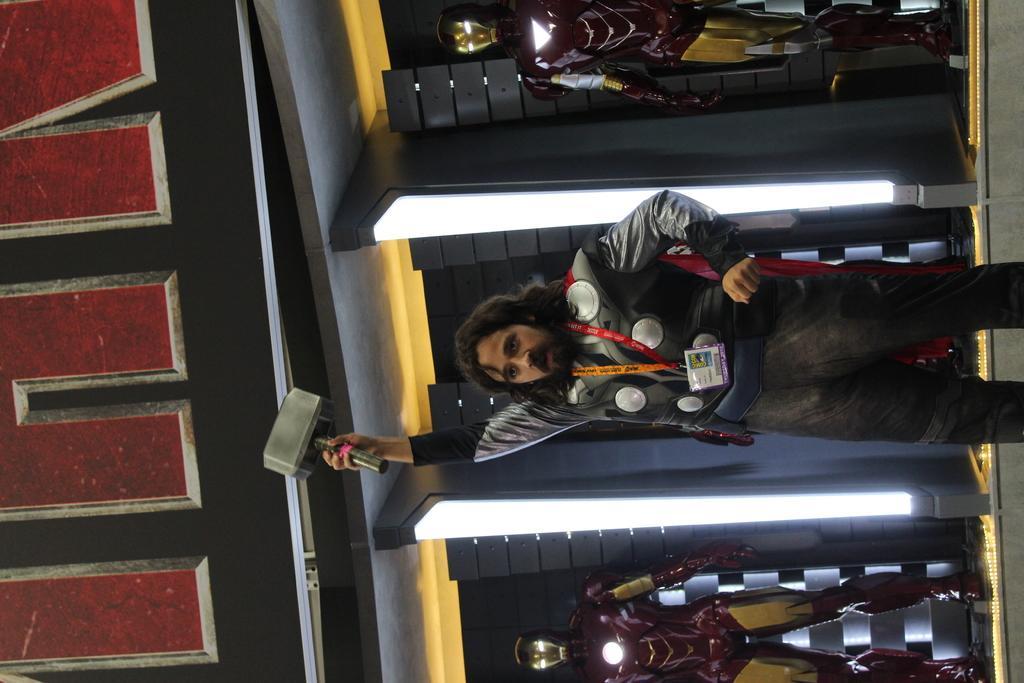How would you summarize this image in a sentence or two? This is a rotated image. In this image we can see there is a person standing and holding a hammer in his hand, behind the person there is a wall. On the right and left side of the image there are robots. 